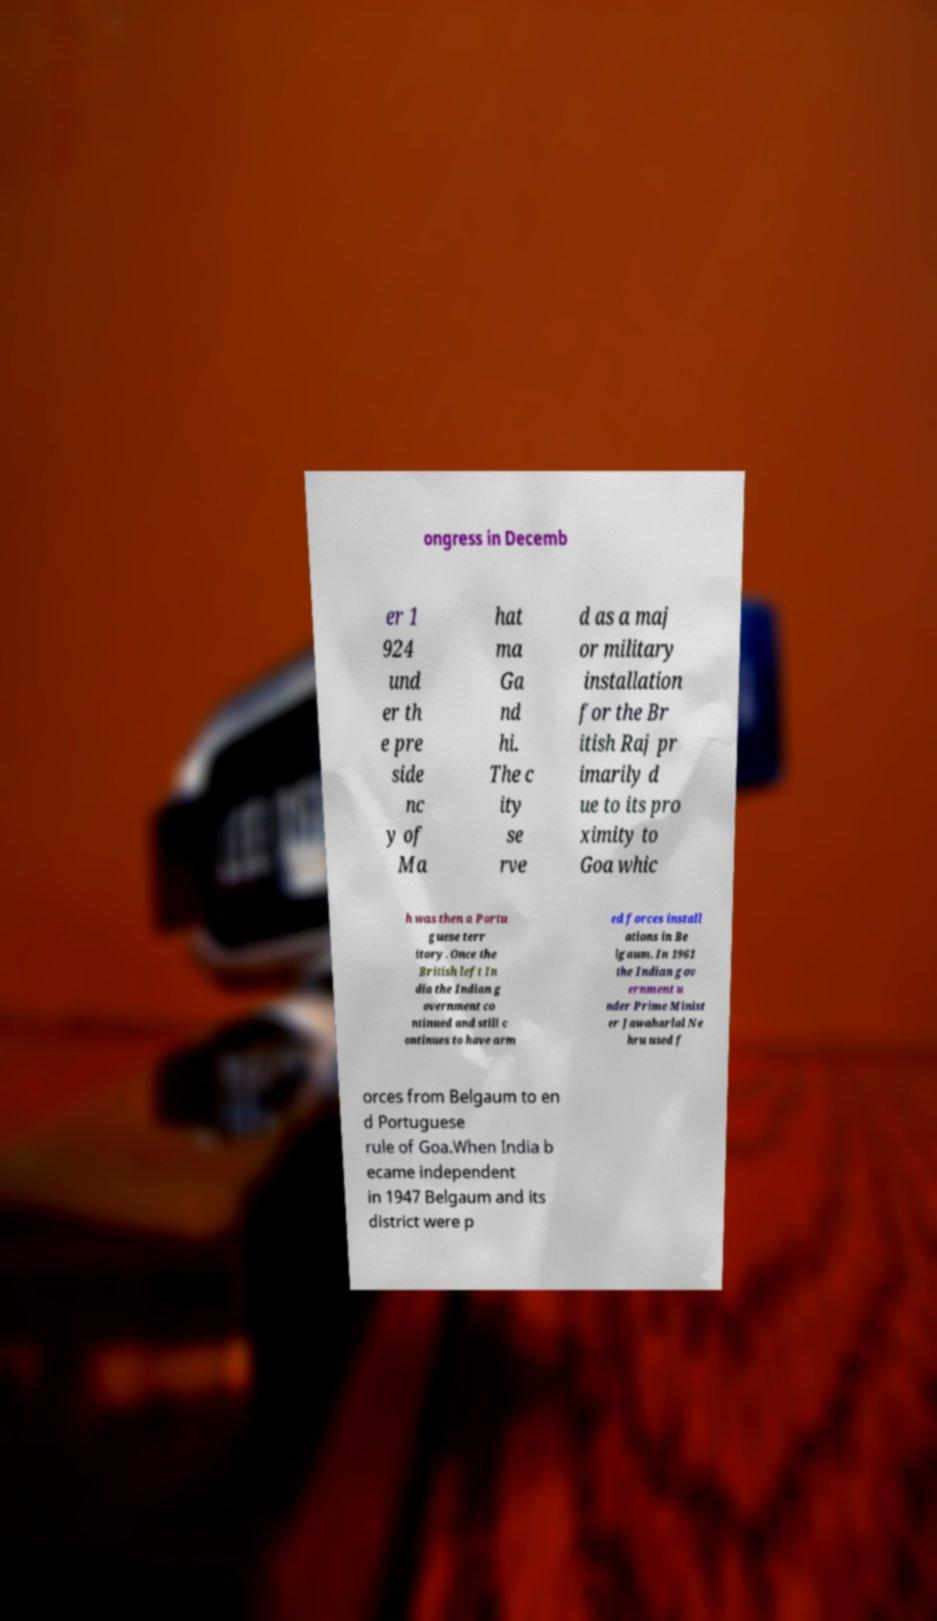Could you extract and type out the text from this image? ongress in Decemb er 1 924 und er th e pre side nc y of Ma hat ma Ga nd hi. The c ity se rve d as a maj or military installation for the Br itish Raj pr imarily d ue to its pro ximity to Goa whic h was then a Portu guese terr itory. Once the British left In dia the Indian g overnment co ntinued and still c ontinues to have arm ed forces install ations in Be lgaum. In 1961 the Indian gov ernment u nder Prime Minist er Jawaharlal Ne hru used f orces from Belgaum to en d Portuguese rule of Goa.When India b ecame independent in 1947 Belgaum and its district were p 